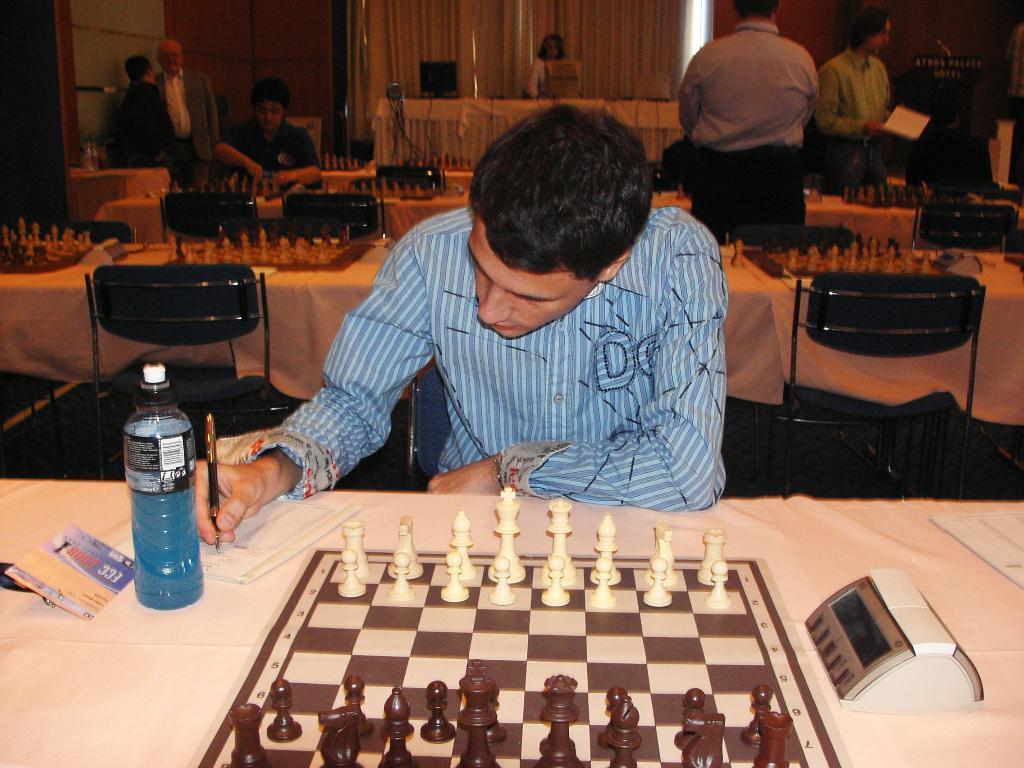How would you summarize this image in a sentence or two? In this picture there is a man, he has a table in front of him with the clock timer there is a chess board with coins arranged and there is a bottle beside him his writing with a pen on a sheet, in the background a woman standing and sitting and a many more chess tables and chairs 